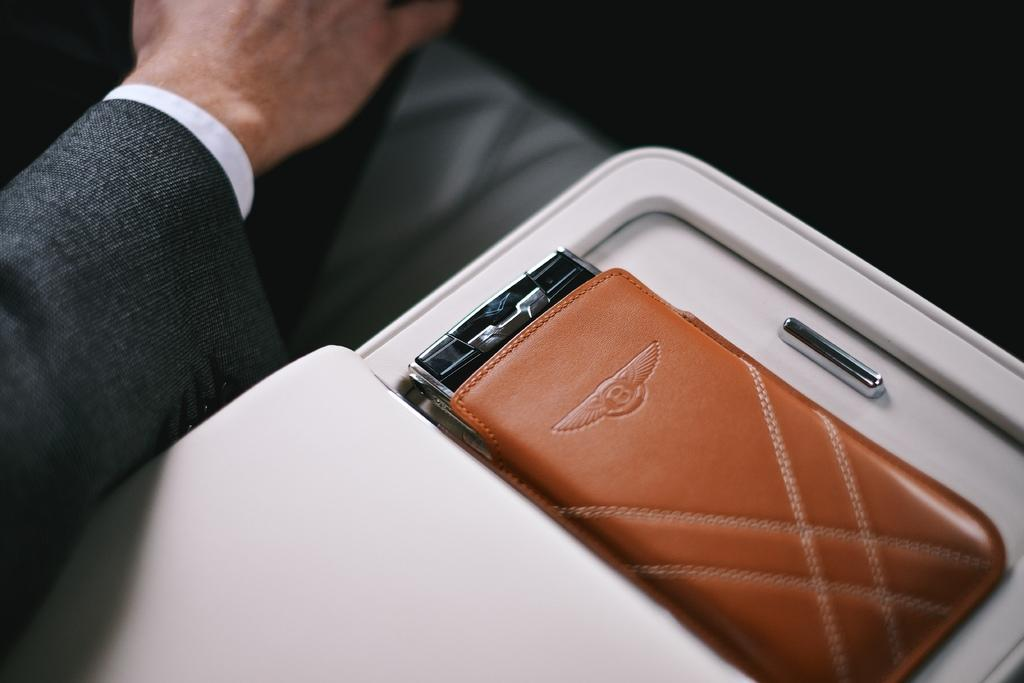What can be seen on the left side of the image? There is a hand of a person on the left side of the image. What is the color of the pouch in the image? The pouch in the image is brown. What is the pouch placed on in the image? The pouch is kept on an object. How many books can be seen in the image? There are no books visible in the image. What type of fang is present in the image? There is no fang present in the image. 